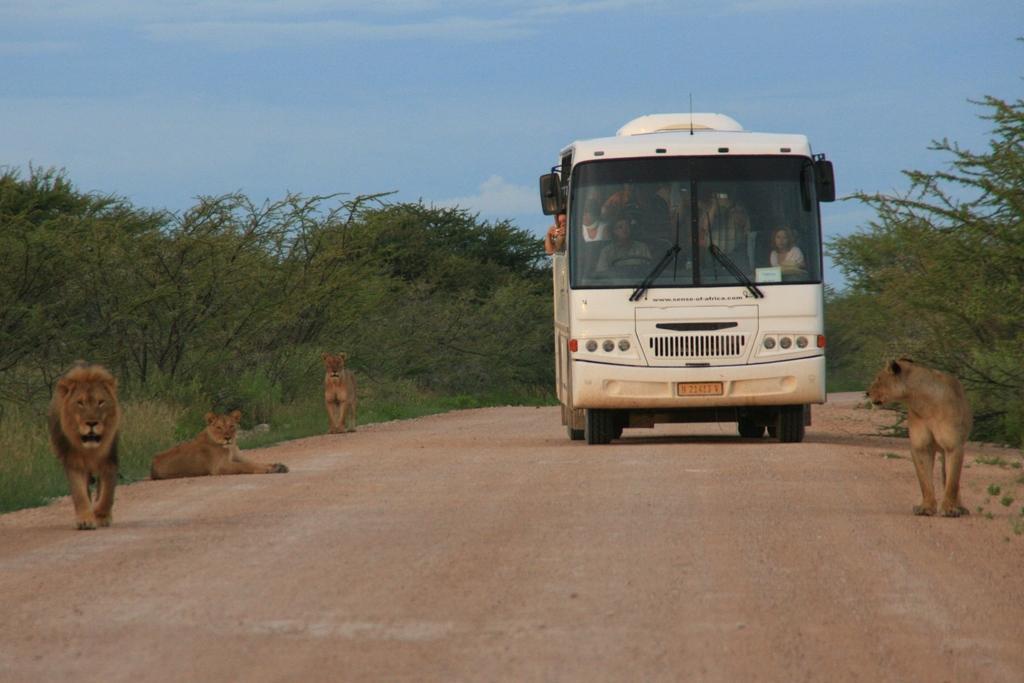In one or two sentences, can you explain what this image depicts? In this image we can see a group of people in a bus. In front of the bus there are four lions and beside the bus there are group of trees. At the top we can see the sky. 